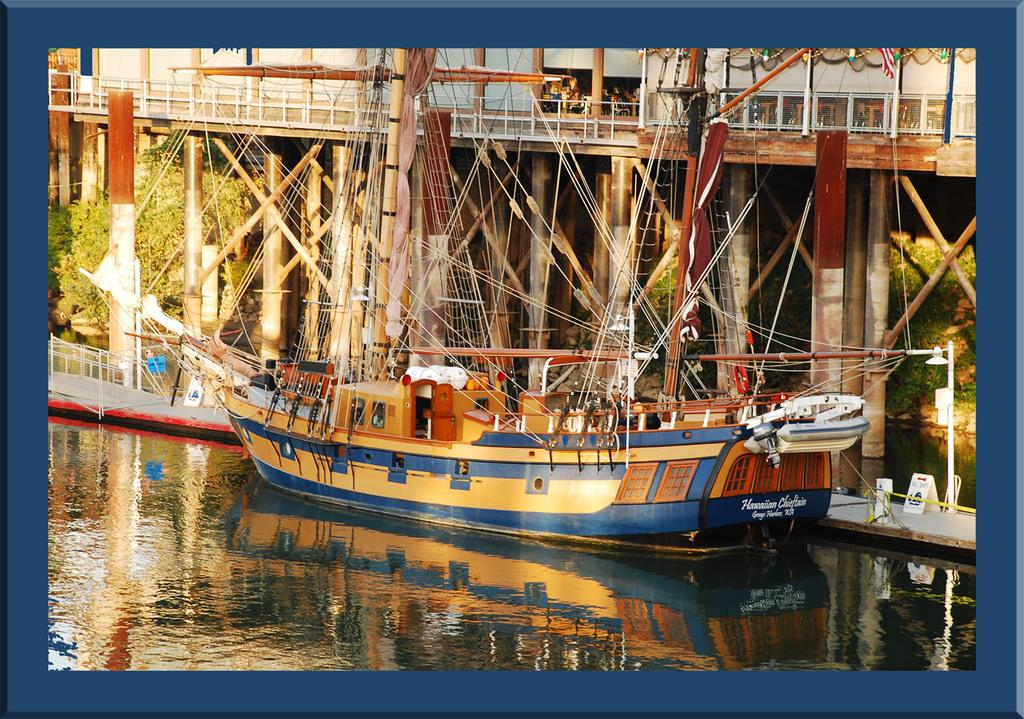What is the main subject of the image? The main subject of the image is a boat. Where is the boat located? The boat is on a water body. What can be seen in the background of the image? There is a bridge and trees in the background of the image. What type of seed can be seen growing on the bridge in the image? There is no seed growing on the bridge in the image; the bridge is a man-made structure without any vegetation. 